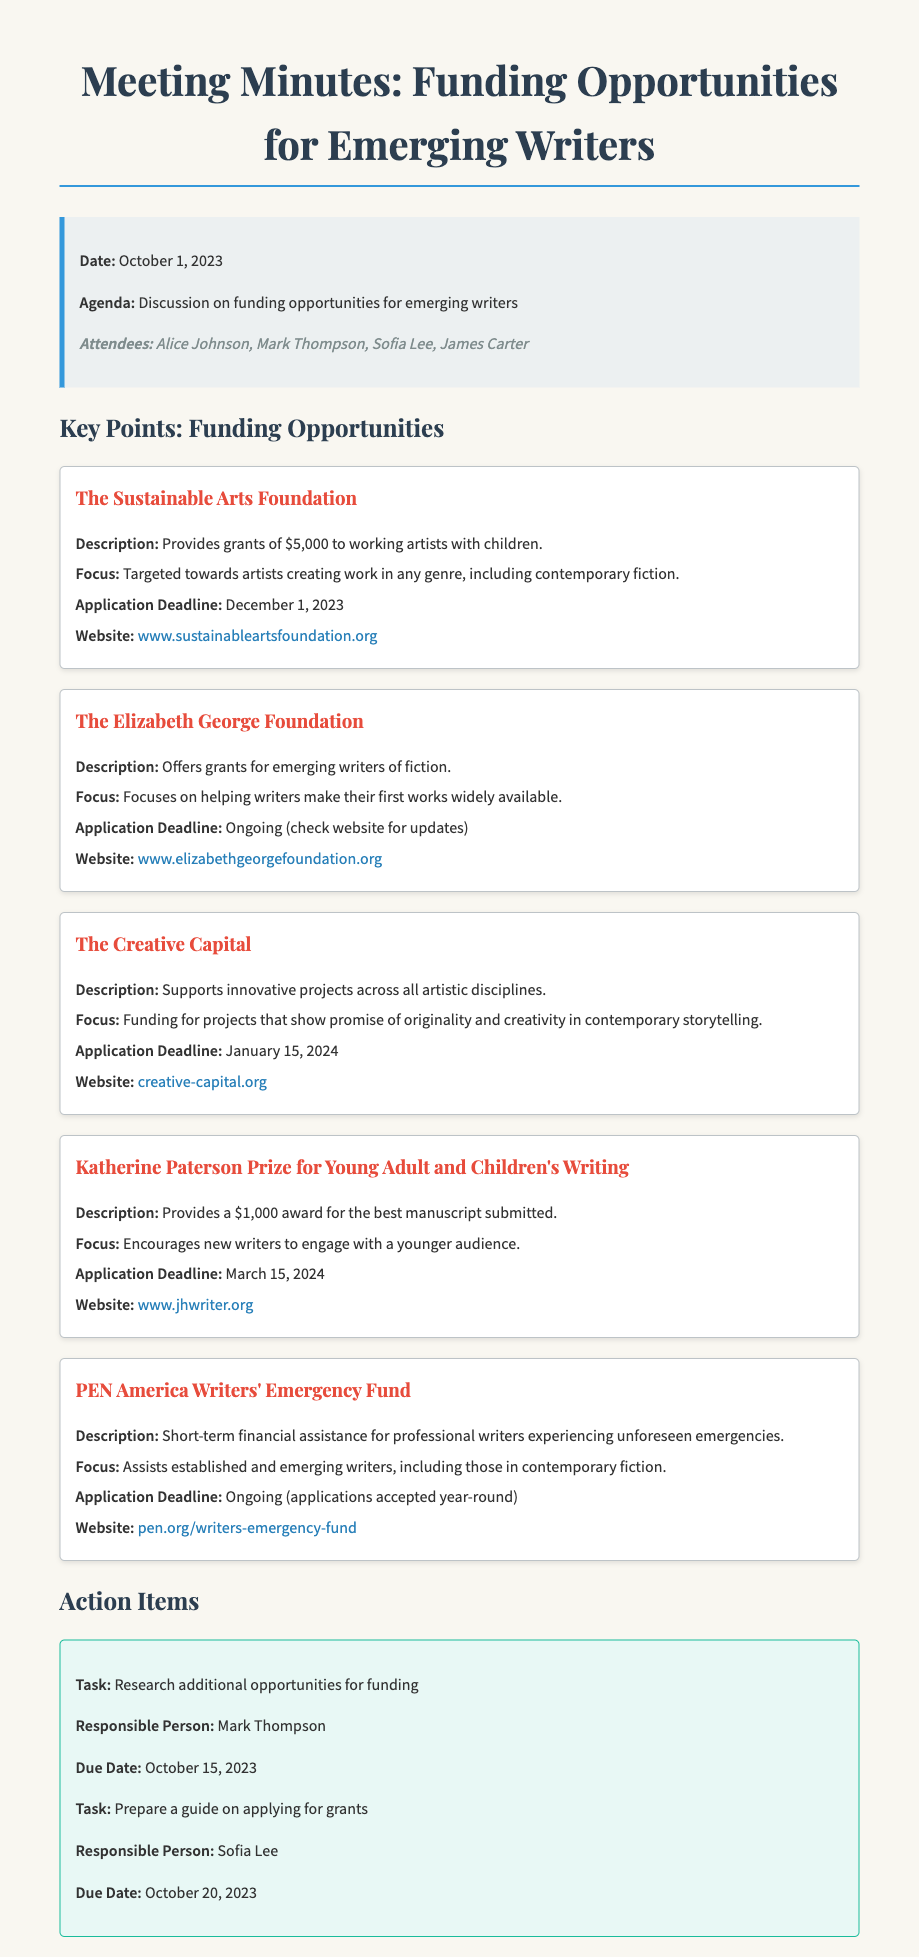what is the date of the meeting? The date of the meeting is provided in the meeting information section of the document.
Answer: October 1, 2023 what is the grant amount for The Sustainable Arts Foundation? The document states that The Sustainable Arts Foundation provides grants of $5,000.
Answer: $5,000 who is responsible for preparing a guide on applying for grants? In the action items section, it is mentioned who is responsible for each task.
Answer: Sofia Lee what is the application deadline for The Creative Capital? The document lists the application deadline for The Creative Capital.
Answer: January 15, 2024 what is the focus of The Elizabeth George Foundation? The document describes the focus of The Elizabeth George Foundation regarding the type of writers it aims to support.
Answer: Emerging writers of fiction how much is the Katherine Paterson Prize for Young Adult and Children's Writing? The document states the amount of the prize provided by the Katherine Paterson Prize.
Answer: $1,000 what task is Mark Thompson responsible for? The action items indicate the specific tasks assigned to attendees at the meeting.
Answer: Research additional opportunities for funding does PEN America Writers' Emergency Fund have a specific application deadline? The document indicates whether there is a specific application deadline for PEN America Writers' Emergency Fund.
Answer: Ongoing what type of funding does The Creative Capital support? The document explains the type of projects that The Creative Capital is interested in supporting.
Answer: Innovative projects across all artistic disciplines 